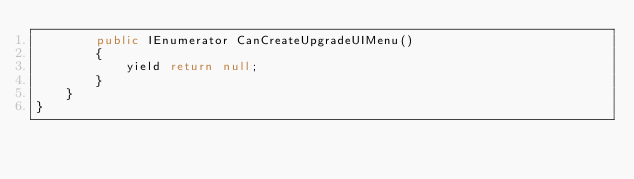Convert code to text. <code><loc_0><loc_0><loc_500><loc_500><_C#_>        public IEnumerator CanCreateUpgradeUIMenu()
        {
            yield return null;
        }
    }
}
</code> 